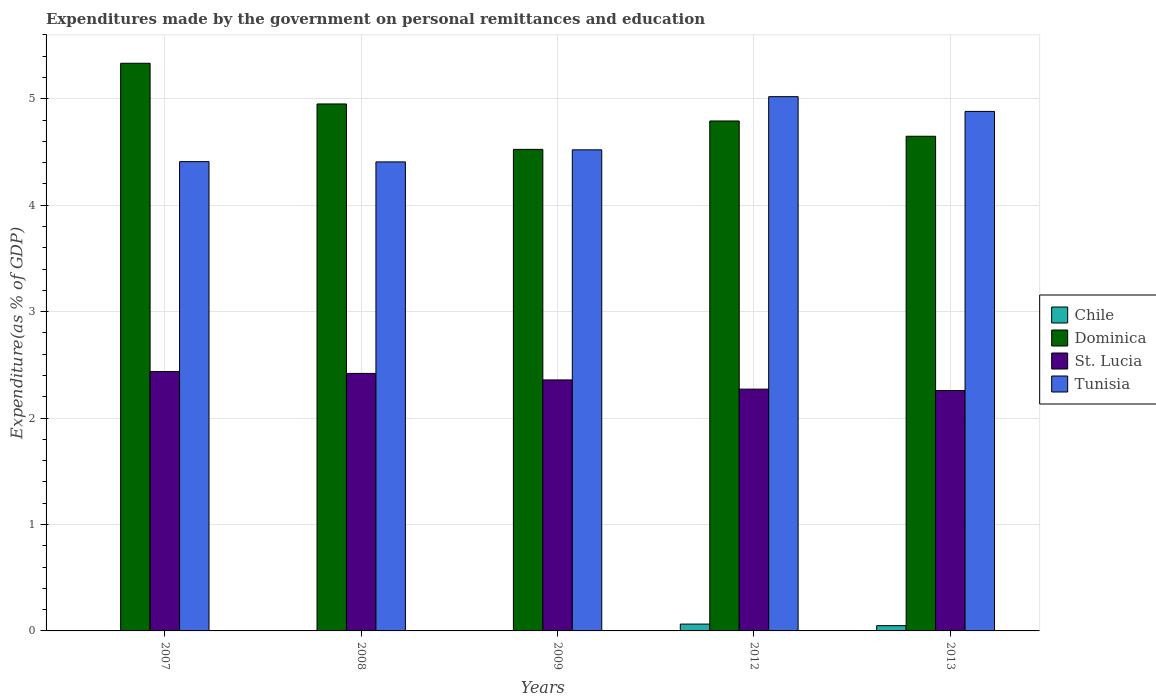How many different coloured bars are there?
Provide a short and direct response. 4. Are the number of bars per tick equal to the number of legend labels?
Your response must be concise. Yes. How many bars are there on the 5th tick from the right?
Your answer should be compact. 4. In how many cases, is the number of bars for a given year not equal to the number of legend labels?
Your answer should be very brief. 0. What is the expenditures made by the government on personal remittances and education in Chile in 2012?
Your answer should be compact. 0.06. Across all years, what is the maximum expenditures made by the government on personal remittances and education in Dominica?
Offer a terse response. 5.33. Across all years, what is the minimum expenditures made by the government on personal remittances and education in Tunisia?
Your answer should be very brief. 4.41. In which year was the expenditures made by the government on personal remittances and education in Chile minimum?
Ensure brevity in your answer.  2008. What is the total expenditures made by the government on personal remittances and education in St. Lucia in the graph?
Give a very brief answer. 11.75. What is the difference between the expenditures made by the government on personal remittances and education in St. Lucia in 2009 and that in 2012?
Ensure brevity in your answer.  0.09. What is the difference between the expenditures made by the government on personal remittances and education in Chile in 2007 and the expenditures made by the government on personal remittances and education in Tunisia in 2009?
Offer a terse response. -4.52. What is the average expenditures made by the government on personal remittances and education in Tunisia per year?
Your answer should be compact. 4.65. In the year 2013, what is the difference between the expenditures made by the government on personal remittances and education in Dominica and expenditures made by the government on personal remittances and education in Chile?
Provide a short and direct response. 4.6. What is the ratio of the expenditures made by the government on personal remittances and education in Tunisia in 2008 to that in 2009?
Make the answer very short. 0.97. Is the difference between the expenditures made by the government on personal remittances and education in Dominica in 2012 and 2013 greater than the difference between the expenditures made by the government on personal remittances and education in Chile in 2012 and 2013?
Ensure brevity in your answer.  Yes. What is the difference between the highest and the second highest expenditures made by the government on personal remittances and education in Tunisia?
Keep it short and to the point. 0.14. What is the difference between the highest and the lowest expenditures made by the government on personal remittances and education in Tunisia?
Ensure brevity in your answer.  0.61. Is it the case that in every year, the sum of the expenditures made by the government on personal remittances and education in Chile and expenditures made by the government on personal remittances and education in Dominica is greater than the sum of expenditures made by the government on personal remittances and education in Tunisia and expenditures made by the government on personal remittances and education in St. Lucia?
Offer a very short reply. Yes. What does the 3rd bar from the right in 2013 represents?
Your answer should be very brief. Dominica. Are all the bars in the graph horizontal?
Your answer should be compact. No. How many years are there in the graph?
Keep it short and to the point. 5. What is the difference between two consecutive major ticks on the Y-axis?
Your response must be concise. 1. Does the graph contain any zero values?
Give a very brief answer. No. Where does the legend appear in the graph?
Your answer should be compact. Center right. What is the title of the graph?
Offer a very short reply. Expenditures made by the government on personal remittances and education. What is the label or title of the Y-axis?
Provide a succinct answer. Expenditure(as % of GDP). What is the Expenditure(as % of GDP) of Chile in 2007?
Provide a short and direct response. 0. What is the Expenditure(as % of GDP) in Dominica in 2007?
Give a very brief answer. 5.33. What is the Expenditure(as % of GDP) in St. Lucia in 2007?
Make the answer very short. 2.44. What is the Expenditure(as % of GDP) in Tunisia in 2007?
Your answer should be very brief. 4.41. What is the Expenditure(as % of GDP) in Chile in 2008?
Offer a very short reply. 0. What is the Expenditure(as % of GDP) of Dominica in 2008?
Your response must be concise. 4.95. What is the Expenditure(as % of GDP) in St. Lucia in 2008?
Offer a terse response. 2.42. What is the Expenditure(as % of GDP) in Tunisia in 2008?
Your response must be concise. 4.41. What is the Expenditure(as % of GDP) in Chile in 2009?
Keep it short and to the point. 0. What is the Expenditure(as % of GDP) in Dominica in 2009?
Make the answer very short. 4.52. What is the Expenditure(as % of GDP) in St. Lucia in 2009?
Your answer should be very brief. 2.36. What is the Expenditure(as % of GDP) in Tunisia in 2009?
Offer a terse response. 4.52. What is the Expenditure(as % of GDP) of Chile in 2012?
Give a very brief answer. 0.06. What is the Expenditure(as % of GDP) of Dominica in 2012?
Your answer should be very brief. 4.79. What is the Expenditure(as % of GDP) in St. Lucia in 2012?
Ensure brevity in your answer.  2.27. What is the Expenditure(as % of GDP) in Tunisia in 2012?
Your response must be concise. 5.02. What is the Expenditure(as % of GDP) of Chile in 2013?
Offer a terse response. 0.05. What is the Expenditure(as % of GDP) of Dominica in 2013?
Ensure brevity in your answer.  4.65. What is the Expenditure(as % of GDP) of St. Lucia in 2013?
Provide a short and direct response. 2.26. What is the Expenditure(as % of GDP) of Tunisia in 2013?
Your answer should be compact. 4.88. Across all years, what is the maximum Expenditure(as % of GDP) of Chile?
Make the answer very short. 0.06. Across all years, what is the maximum Expenditure(as % of GDP) of Dominica?
Your response must be concise. 5.33. Across all years, what is the maximum Expenditure(as % of GDP) of St. Lucia?
Make the answer very short. 2.44. Across all years, what is the maximum Expenditure(as % of GDP) of Tunisia?
Your answer should be compact. 5.02. Across all years, what is the minimum Expenditure(as % of GDP) in Chile?
Offer a terse response. 0. Across all years, what is the minimum Expenditure(as % of GDP) in Dominica?
Your response must be concise. 4.52. Across all years, what is the minimum Expenditure(as % of GDP) in St. Lucia?
Ensure brevity in your answer.  2.26. Across all years, what is the minimum Expenditure(as % of GDP) in Tunisia?
Offer a terse response. 4.41. What is the total Expenditure(as % of GDP) in Chile in the graph?
Your answer should be compact. 0.12. What is the total Expenditure(as % of GDP) of Dominica in the graph?
Provide a short and direct response. 24.25. What is the total Expenditure(as % of GDP) of St. Lucia in the graph?
Offer a terse response. 11.75. What is the total Expenditure(as % of GDP) of Tunisia in the graph?
Provide a short and direct response. 23.24. What is the difference between the Expenditure(as % of GDP) of Dominica in 2007 and that in 2008?
Keep it short and to the point. 0.38. What is the difference between the Expenditure(as % of GDP) in St. Lucia in 2007 and that in 2008?
Your answer should be compact. 0.02. What is the difference between the Expenditure(as % of GDP) of Tunisia in 2007 and that in 2008?
Give a very brief answer. 0. What is the difference between the Expenditure(as % of GDP) of Chile in 2007 and that in 2009?
Keep it short and to the point. -0. What is the difference between the Expenditure(as % of GDP) of Dominica in 2007 and that in 2009?
Make the answer very short. 0.81. What is the difference between the Expenditure(as % of GDP) in St. Lucia in 2007 and that in 2009?
Provide a short and direct response. 0.08. What is the difference between the Expenditure(as % of GDP) of Tunisia in 2007 and that in 2009?
Offer a very short reply. -0.11. What is the difference between the Expenditure(as % of GDP) of Chile in 2007 and that in 2012?
Keep it short and to the point. -0.06. What is the difference between the Expenditure(as % of GDP) of Dominica in 2007 and that in 2012?
Your answer should be compact. 0.54. What is the difference between the Expenditure(as % of GDP) of St. Lucia in 2007 and that in 2012?
Ensure brevity in your answer.  0.17. What is the difference between the Expenditure(as % of GDP) of Tunisia in 2007 and that in 2012?
Provide a succinct answer. -0.61. What is the difference between the Expenditure(as % of GDP) of Chile in 2007 and that in 2013?
Your answer should be compact. -0.05. What is the difference between the Expenditure(as % of GDP) in Dominica in 2007 and that in 2013?
Your answer should be very brief. 0.69. What is the difference between the Expenditure(as % of GDP) of St. Lucia in 2007 and that in 2013?
Provide a short and direct response. 0.18. What is the difference between the Expenditure(as % of GDP) in Tunisia in 2007 and that in 2013?
Provide a succinct answer. -0.47. What is the difference between the Expenditure(as % of GDP) in Chile in 2008 and that in 2009?
Your answer should be very brief. -0. What is the difference between the Expenditure(as % of GDP) in Dominica in 2008 and that in 2009?
Give a very brief answer. 0.43. What is the difference between the Expenditure(as % of GDP) in St. Lucia in 2008 and that in 2009?
Your response must be concise. 0.06. What is the difference between the Expenditure(as % of GDP) in Tunisia in 2008 and that in 2009?
Offer a very short reply. -0.11. What is the difference between the Expenditure(as % of GDP) of Chile in 2008 and that in 2012?
Offer a very short reply. -0.06. What is the difference between the Expenditure(as % of GDP) of Dominica in 2008 and that in 2012?
Your answer should be compact. 0.16. What is the difference between the Expenditure(as % of GDP) in St. Lucia in 2008 and that in 2012?
Give a very brief answer. 0.15. What is the difference between the Expenditure(as % of GDP) of Tunisia in 2008 and that in 2012?
Offer a very short reply. -0.61. What is the difference between the Expenditure(as % of GDP) in Chile in 2008 and that in 2013?
Offer a very short reply. -0.05. What is the difference between the Expenditure(as % of GDP) in Dominica in 2008 and that in 2013?
Ensure brevity in your answer.  0.3. What is the difference between the Expenditure(as % of GDP) in St. Lucia in 2008 and that in 2013?
Make the answer very short. 0.16. What is the difference between the Expenditure(as % of GDP) of Tunisia in 2008 and that in 2013?
Ensure brevity in your answer.  -0.47. What is the difference between the Expenditure(as % of GDP) in Chile in 2009 and that in 2012?
Make the answer very short. -0.06. What is the difference between the Expenditure(as % of GDP) of Dominica in 2009 and that in 2012?
Your answer should be compact. -0.27. What is the difference between the Expenditure(as % of GDP) in St. Lucia in 2009 and that in 2012?
Your answer should be compact. 0.09. What is the difference between the Expenditure(as % of GDP) of Tunisia in 2009 and that in 2012?
Provide a succinct answer. -0.5. What is the difference between the Expenditure(as % of GDP) in Chile in 2009 and that in 2013?
Offer a terse response. -0.05. What is the difference between the Expenditure(as % of GDP) of Dominica in 2009 and that in 2013?
Give a very brief answer. -0.12. What is the difference between the Expenditure(as % of GDP) in St. Lucia in 2009 and that in 2013?
Your answer should be very brief. 0.1. What is the difference between the Expenditure(as % of GDP) in Tunisia in 2009 and that in 2013?
Your answer should be compact. -0.36. What is the difference between the Expenditure(as % of GDP) of Chile in 2012 and that in 2013?
Your answer should be compact. 0.01. What is the difference between the Expenditure(as % of GDP) in Dominica in 2012 and that in 2013?
Make the answer very short. 0.14. What is the difference between the Expenditure(as % of GDP) of St. Lucia in 2012 and that in 2013?
Offer a terse response. 0.01. What is the difference between the Expenditure(as % of GDP) of Tunisia in 2012 and that in 2013?
Offer a terse response. 0.14. What is the difference between the Expenditure(as % of GDP) of Chile in 2007 and the Expenditure(as % of GDP) of Dominica in 2008?
Your answer should be very brief. -4.95. What is the difference between the Expenditure(as % of GDP) in Chile in 2007 and the Expenditure(as % of GDP) in St. Lucia in 2008?
Your answer should be very brief. -2.42. What is the difference between the Expenditure(as % of GDP) of Chile in 2007 and the Expenditure(as % of GDP) of Tunisia in 2008?
Make the answer very short. -4.41. What is the difference between the Expenditure(as % of GDP) of Dominica in 2007 and the Expenditure(as % of GDP) of St. Lucia in 2008?
Ensure brevity in your answer.  2.91. What is the difference between the Expenditure(as % of GDP) in Dominica in 2007 and the Expenditure(as % of GDP) in Tunisia in 2008?
Ensure brevity in your answer.  0.93. What is the difference between the Expenditure(as % of GDP) of St. Lucia in 2007 and the Expenditure(as % of GDP) of Tunisia in 2008?
Keep it short and to the point. -1.97. What is the difference between the Expenditure(as % of GDP) in Chile in 2007 and the Expenditure(as % of GDP) in Dominica in 2009?
Provide a succinct answer. -4.52. What is the difference between the Expenditure(as % of GDP) in Chile in 2007 and the Expenditure(as % of GDP) in St. Lucia in 2009?
Provide a succinct answer. -2.36. What is the difference between the Expenditure(as % of GDP) in Chile in 2007 and the Expenditure(as % of GDP) in Tunisia in 2009?
Ensure brevity in your answer.  -4.52. What is the difference between the Expenditure(as % of GDP) of Dominica in 2007 and the Expenditure(as % of GDP) of St. Lucia in 2009?
Ensure brevity in your answer.  2.98. What is the difference between the Expenditure(as % of GDP) in Dominica in 2007 and the Expenditure(as % of GDP) in Tunisia in 2009?
Your answer should be compact. 0.81. What is the difference between the Expenditure(as % of GDP) of St. Lucia in 2007 and the Expenditure(as % of GDP) of Tunisia in 2009?
Give a very brief answer. -2.08. What is the difference between the Expenditure(as % of GDP) of Chile in 2007 and the Expenditure(as % of GDP) of Dominica in 2012?
Make the answer very short. -4.79. What is the difference between the Expenditure(as % of GDP) of Chile in 2007 and the Expenditure(as % of GDP) of St. Lucia in 2012?
Keep it short and to the point. -2.27. What is the difference between the Expenditure(as % of GDP) of Chile in 2007 and the Expenditure(as % of GDP) of Tunisia in 2012?
Keep it short and to the point. -5.02. What is the difference between the Expenditure(as % of GDP) in Dominica in 2007 and the Expenditure(as % of GDP) in St. Lucia in 2012?
Provide a succinct answer. 3.06. What is the difference between the Expenditure(as % of GDP) in Dominica in 2007 and the Expenditure(as % of GDP) in Tunisia in 2012?
Give a very brief answer. 0.31. What is the difference between the Expenditure(as % of GDP) of St. Lucia in 2007 and the Expenditure(as % of GDP) of Tunisia in 2012?
Provide a succinct answer. -2.58. What is the difference between the Expenditure(as % of GDP) in Chile in 2007 and the Expenditure(as % of GDP) in Dominica in 2013?
Offer a very short reply. -4.65. What is the difference between the Expenditure(as % of GDP) in Chile in 2007 and the Expenditure(as % of GDP) in St. Lucia in 2013?
Provide a succinct answer. -2.26. What is the difference between the Expenditure(as % of GDP) in Chile in 2007 and the Expenditure(as % of GDP) in Tunisia in 2013?
Provide a short and direct response. -4.88. What is the difference between the Expenditure(as % of GDP) of Dominica in 2007 and the Expenditure(as % of GDP) of St. Lucia in 2013?
Ensure brevity in your answer.  3.07. What is the difference between the Expenditure(as % of GDP) in Dominica in 2007 and the Expenditure(as % of GDP) in Tunisia in 2013?
Offer a terse response. 0.45. What is the difference between the Expenditure(as % of GDP) of St. Lucia in 2007 and the Expenditure(as % of GDP) of Tunisia in 2013?
Offer a very short reply. -2.44. What is the difference between the Expenditure(as % of GDP) of Chile in 2008 and the Expenditure(as % of GDP) of Dominica in 2009?
Keep it short and to the point. -4.52. What is the difference between the Expenditure(as % of GDP) in Chile in 2008 and the Expenditure(as % of GDP) in St. Lucia in 2009?
Offer a very short reply. -2.36. What is the difference between the Expenditure(as % of GDP) in Chile in 2008 and the Expenditure(as % of GDP) in Tunisia in 2009?
Your response must be concise. -4.52. What is the difference between the Expenditure(as % of GDP) of Dominica in 2008 and the Expenditure(as % of GDP) of St. Lucia in 2009?
Your answer should be very brief. 2.59. What is the difference between the Expenditure(as % of GDP) in Dominica in 2008 and the Expenditure(as % of GDP) in Tunisia in 2009?
Provide a succinct answer. 0.43. What is the difference between the Expenditure(as % of GDP) of St. Lucia in 2008 and the Expenditure(as % of GDP) of Tunisia in 2009?
Your answer should be compact. -2.1. What is the difference between the Expenditure(as % of GDP) in Chile in 2008 and the Expenditure(as % of GDP) in Dominica in 2012?
Give a very brief answer. -4.79. What is the difference between the Expenditure(as % of GDP) of Chile in 2008 and the Expenditure(as % of GDP) of St. Lucia in 2012?
Provide a short and direct response. -2.27. What is the difference between the Expenditure(as % of GDP) of Chile in 2008 and the Expenditure(as % of GDP) of Tunisia in 2012?
Make the answer very short. -5.02. What is the difference between the Expenditure(as % of GDP) of Dominica in 2008 and the Expenditure(as % of GDP) of St. Lucia in 2012?
Your response must be concise. 2.68. What is the difference between the Expenditure(as % of GDP) of Dominica in 2008 and the Expenditure(as % of GDP) of Tunisia in 2012?
Give a very brief answer. -0.07. What is the difference between the Expenditure(as % of GDP) of St. Lucia in 2008 and the Expenditure(as % of GDP) of Tunisia in 2012?
Offer a terse response. -2.6. What is the difference between the Expenditure(as % of GDP) of Chile in 2008 and the Expenditure(as % of GDP) of Dominica in 2013?
Your answer should be very brief. -4.65. What is the difference between the Expenditure(as % of GDP) in Chile in 2008 and the Expenditure(as % of GDP) in St. Lucia in 2013?
Ensure brevity in your answer.  -2.26. What is the difference between the Expenditure(as % of GDP) in Chile in 2008 and the Expenditure(as % of GDP) in Tunisia in 2013?
Ensure brevity in your answer.  -4.88. What is the difference between the Expenditure(as % of GDP) of Dominica in 2008 and the Expenditure(as % of GDP) of St. Lucia in 2013?
Your answer should be very brief. 2.69. What is the difference between the Expenditure(as % of GDP) in Dominica in 2008 and the Expenditure(as % of GDP) in Tunisia in 2013?
Provide a succinct answer. 0.07. What is the difference between the Expenditure(as % of GDP) in St. Lucia in 2008 and the Expenditure(as % of GDP) in Tunisia in 2013?
Ensure brevity in your answer.  -2.46. What is the difference between the Expenditure(as % of GDP) of Chile in 2009 and the Expenditure(as % of GDP) of Dominica in 2012?
Keep it short and to the point. -4.79. What is the difference between the Expenditure(as % of GDP) of Chile in 2009 and the Expenditure(as % of GDP) of St. Lucia in 2012?
Provide a succinct answer. -2.27. What is the difference between the Expenditure(as % of GDP) in Chile in 2009 and the Expenditure(as % of GDP) in Tunisia in 2012?
Provide a succinct answer. -5.02. What is the difference between the Expenditure(as % of GDP) of Dominica in 2009 and the Expenditure(as % of GDP) of St. Lucia in 2012?
Offer a terse response. 2.25. What is the difference between the Expenditure(as % of GDP) of Dominica in 2009 and the Expenditure(as % of GDP) of Tunisia in 2012?
Offer a terse response. -0.5. What is the difference between the Expenditure(as % of GDP) of St. Lucia in 2009 and the Expenditure(as % of GDP) of Tunisia in 2012?
Your answer should be compact. -2.66. What is the difference between the Expenditure(as % of GDP) of Chile in 2009 and the Expenditure(as % of GDP) of Dominica in 2013?
Your response must be concise. -4.65. What is the difference between the Expenditure(as % of GDP) in Chile in 2009 and the Expenditure(as % of GDP) in St. Lucia in 2013?
Give a very brief answer. -2.26. What is the difference between the Expenditure(as % of GDP) in Chile in 2009 and the Expenditure(as % of GDP) in Tunisia in 2013?
Ensure brevity in your answer.  -4.88. What is the difference between the Expenditure(as % of GDP) in Dominica in 2009 and the Expenditure(as % of GDP) in St. Lucia in 2013?
Provide a succinct answer. 2.27. What is the difference between the Expenditure(as % of GDP) of Dominica in 2009 and the Expenditure(as % of GDP) of Tunisia in 2013?
Ensure brevity in your answer.  -0.36. What is the difference between the Expenditure(as % of GDP) in St. Lucia in 2009 and the Expenditure(as % of GDP) in Tunisia in 2013?
Offer a very short reply. -2.52. What is the difference between the Expenditure(as % of GDP) of Chile in 2012 and the Expenditure(as % of GDP) of Dominica in 2013?
Your answer should be very brief. -4.58. What is the difference between the Expenditure(as % of GDP) in Chile in 2012 and the Expenditure(as % of GDP) in St. Lucia in 2013?
Provide a succinct answer. -2.19. What is the difference between the Expenditure(as % of GDP) of Chile in 2012 and the Expenditure(as % of GDP) of Tunisia in 2013?
Keep it short and to the point. -4.82. What is the difference between the Expenditure(as % of GDP) in Dominica in 2012 and the Expenditure(as % of GDP) in St. Lucia in 2013?
Provide a succinct answer. 2.53. What is the difference between the Expenditure(as % of GDP) in Dominica in 2012 and the Expenditure(as % of GDP) in Tunisia in 2013?
Make the answer very short. -0.09. What is the difference between the Expenditure(as % of GDP) in St. Lucia in 2012 and the Expenditure(as % of GDP) in Tunisia in 2013?
Provide a succinct answer. -2.61. What is the average Expenditure(as % of GDP) of Chile per year?
Your answer should be very brief. 0.02. What is the average Expenditure(as % of GDP) of Dominica per year?
Offer a very short reply. 4.85. What is the average Expenditure(as % of GDP) of St. Lucia per year?
Your answer should be very brief. 2.35. What is the average Expenditure(as % of GDP) in Tunisia per year?
Your response must be concise. 4.65. In the year 2007, what is the difference between the Expenditure(as % of GDP) in Chile and Expenditure(as % of GDP) in Dominica?
Keep it short and to the point. -5.33. In the year 2007, what is the difference between the Expenditure(as % of GDP) of Chile and Expenditure(as % of GDP) of St. Lucia?
Make the answer very short. -2.44. In the year 2007, what is the difference between the Expenditure(as % of GDP) in Chile and Expenditure(as % of GDP) in Tunisia?
Your answer should be compact. -4.41. In the year 2007, what is the difference between the Expenditure(as % of GDP) of Dominica and Expenditure(as % of GDP) of St. Lucia?
Provide a short and direct response. 2.9. In the year 2007, what is the difference between the Expenditure(as % of GDP) of Dominica and Expenditure(as % of GDP) of Tunisia?
Offer a terse response. 0.92. In the year 2007, what is the difference between the Expenditure(as % of GDP) in St. Lucia and Expenditure(as % of GDP) in Tunisia?
Your response must be concise. -1.97. In the year 2008, what is the difference between the Expenditure(as % of GDP) of Chile and Expenditure(as % of GDP) of Dominica?
Offer a very short reply. -4.95. In the year 2008, what is the difference between the Expenditure(as % of GDP) in Chile and Expenditure(as % of GDP) in St. Lucia?
Keep it short and to the point. -2.42. In the year 2008, what is the difference between the Expenditure(as % of GDP) of Chile and Expenditure(as % of GDP) of Tunisia?
Keep it short and to the point. -4.41. In the year 2008, what is the difference between the Expenditure(as % of GDP) in Dominica and Expenditure(as % of GDP) in St. Lucia?
Provide a short and direct response. 2.53. In the year 2008, what is the difference between the Expenditure(as % of GDP) of Dominica and Expenditure(as % of GDP) of Tunisia?
Your answer should be very brief. 0.54. In the year 2008, what is the difference between the Expenditure(as % of GDP) in St. Lucia and Expenditure(as % of GDP) in Tunisia?
Your answer should be compact. -1.99. In the year 2009, what is the difference between the Expenditure(as % of GDP) of Chile and Expenditure(as % of GDP) of Dominica?
Your answer should be compact. -4.52. In the year 2009, what is the difference between the Expenditure(as % of GDP) in Chile and Expenditure(as % of GDP) in St. Lucia?
Provide a succinct answer. -2.36. In the year 2009, what is the difference between the Expenditure(as % of GDP) of Chile and Expenditure(as % of GDP) of Tunisia?
Offer a very short reply. -4.52. In the year 2009, what is the difference between the Expenditure(as % of GDP) in Dominica and Expenditure(as % of GDP) in St. Lucia?
Offer a very short reply. 2.17. In the year 2009, what is the difference between the Expenditure(as % of GDP) of Dominica and Expenditure(as % of GDP) of Tunisia?
Offer a very short reply. 0. In the year 2009, what is the difference between the Expenditure(as % of GDP) of St. Lucia and Expenditure(as % of GDP) of Tunisia?
Offer a terse response. -2.16. In the year 2012, what is the difference between the Expenditure(as % of GDP) of Chile and Expenditure(as % of GDP) of Dominica?
Your response must be concise. -4.73. In the year 2012, what is the difference between the Expenditure(as % of GDP) of Chile and Expenditure(as % of GDP) of St. Lucia?
Offer a very short reply. -2.21. In the year 2012, what is the difference between the Expenditure(as % of GDP) of Chile and Expenditure(as % of GDP) of Tunisia?
Offer a terse response. -4.96. In the year 2012, what is the difference between the Expenditure(as % of GDP) of Dominica and Expenditure(as % of GDP) of St. Lucia?
Provide a succinct answer. 2.52. In the year 2012, what is the difference between the Expenditure(as % of GDP) in Dominica and Expenditure(as % of GDP) in Tunisia?
Your answer should be very brief. -0.23. In the year 2012, what is the difference between the Expenditure(as % of GDP) of St. Lucia and Expenditure(as % of GDP) of Tunisia?
Ensure brevity in your answer.  -2.75. In the year 2013, what is the difference between the Expenditure(as % of GDP) of Chile and Expenditure(as % of GDP) of Dominica?
Your response must be concise. -4.6. In the year 2013, what is the difference between the Expenditure(as % of GDP) of Chile and Expenditure(as % of GDP) of St. Lucia?
Offer a terse response. -2.21. In the year 2013, what is the difference between the Expenditure(as % of GDP) in Chile and Expenditure(as % of GDP) in Tunisia?
Provide a succinct answer. -4.83. In the year 2013, what is the difference between the Expenditure(as % of GDP) of Dominica and Expenditure(as % of GDP) of St. Lucia?
Provide a succinct answer. 2.39. In the year 2013, what is the difference between the Expenditure(as % of GDP) of Dominica and Expenditure(as % of GDP) of Tunisia?
Offer a very short reply. -0.23. In the year 2013, what is the difference between the Expenditure(as % of GDP) in St. Lucia and Expenditure(as % of GDP) in Tunisia?
Your response must be concise. -2.62. What is the ratio of the Expenditure(as % of GDP) in Chile in 2007 to that in 2008?
Your response must be concise. 1.04. What is the ratio of the Expenditure(as % of GDP) of Dominica in 2007 to that in 2008?
Your answer should be compact. 1.08. What is the ratio of the Expenditure(as % of GDP) in St. Lucia in 2007 to that in 2008?
Provide a short and direct response. 1.01. What is the ratio of the Expenditure(as % of GDP) in Tunisia in 2007 to that in 2008?
Offer a very short reply. 1. What is the ratio of the Expenditure(as % of GDP) in Chile in 2007 to that in 2009?
Ensure brevity in your answer.  0.56. What is the ratio of the Expenditure(as % of GDP) of Dominica in 2007 to that in 2009?
Offer a terse response. 1.18. What is the ratio of the Expenditure(as % of GDP) in St. Lucia in 2007 to that in 2009?
Offer a terse response. 1.03. What is the ratio of the Expenditure(as % of GDP) in Tunisia in 2007 to that in 2009?
Provide a short and direct response. 0.98. What is the ratio of the Expenditure(as % of GDP) in Chile in 2007 to that in 2012?
Make the answer very short. 0.02. What is the ratio of the Expenditure(as % of GDP) in Dominica in 2007 to that in 2012?
Give a very brief answer. 1.11. What is the ratio of the Expenditure(as % of GDP) in St. Lucia in 2007 to that in 2012?
Give a very brief answer. 1.07. What is the ratio of the Expenditure(as % of GDP) of Tunisia in 2007 to that in 2012?
Provide a short and direct response. 0.88. What is the ratio of the Expenditure(as % of GDP) in Chile in 2007 to that in 2013?
Provide a short and direct response. 0.03. What is the ratio of the Expenditure(as % of GDP) of Dominica in 2007 to that in 2013?
Provide a succinct answer. 1.15. What is the ratio of the Expenditure(as % of GDP) of St. Lucia in 2007 to that in 2013?
Ensure brevity in your answer.  1.08. What is the ratio of the Expenditure(as % of GDP) in Tunisia in 2007 to that in 2013?
Provide a short and direct response. 0.9. What is the ratio of the Expenditure(as % of GDP) in Chile in 2008 to that in 2009?
Your answer should be very brief. 0.54. What is the ratio of the Expenditure(as % of GDP) of Dominica in 2008 to that in 2009?
Offer a terse response. 1.09. What is the ratio of the Expenditure(as % of GDP) in St. Lucia in 2008 to that in 2009?
Make the answer very short. 1.03. What is the ratio of the Expenditure(as % of GDP) in Tunisia in 2008 to that in 2009?
Provide a short and direct response. 0.97. What is the ratio of the Expenditure(as % of GDP) in Chile in 2008 to that in 2012?
Ensure brevity in your answer.  0.02. What is the ratio of the Expenditure(as % of GDP) in Dominica in 2008 to that in 2012?
Provide a succinct answer. 1.03. What is the ratio of the Expenditure(as % of GDP) of St. Lucia in 2008 to that in 2012?
Your response must be concise. 1.06. What is the ratio of the Expenditure(as % of GDP) of Tunisia in 2008 to that in 2012?
Your answer should be very brief. 0.88. What is the ratio of the Expenditure(as % of GDP) of Chile in 2008 to that in 2013?
Give a very brief answer. 0.03. What is the ratio of the Expenditure(as % of GDP) of Dominica in 2008 to that in 2013?
Keep it short and to the point. 1.07. What is the ratio of the Expenditure(as % of GDP) of St. Lucia in 2008 to that in 2013?
Provide a succinct answer. 1.07. What is the ratio of the Expenditure(as % of GDP) of Tunisia in 2008 to that in 2013?
Offer a terse response. 0.9. What is the ratio of the Expenditure(as % of GDP) of Chile in 2009 to that in 2012?
Ensure brevity in your answer.  0.04. What is the ratio of the Expenditure(as % of GDP) of Dominica in 2009 to that in 2012?
Give a very brief answer. 0.94. What is the ratio of the Expenditure(as % of GDP) of St. Lucia in 2009 to that in 2012?
Give a very brief answer. 1.04. What is the ratio of the Expenditure(as % of GDP) in Tunisia in 2009 to that in 2012?
Your response must be concise. 0.9. What is the ratio of the Expenditure(as % of GDP) in Chile in 2009 to that in 2013?
Provide a short and direct response. 0.05. What is the ratio of the Expenditure(as % of GDP) in Dominica in 2009 to that in 2013?
Provide a succinct answer. 0.97. What is the ratio of the Expenditure(as % of GDP) in St. Lucia in 2009 to that in 2013?
Keep it short and to the point. 1.04. What is the ratio of the Expenditure(as % of GDP) in Tunisia in 2009 to that in 2013?
Offer a very short reply. 0.93. What is the ratio of the Expenditure(as % of GDP) in Chile in 2012 to that in 2013?
Make the answer very short. 1.3. What is the ratio of the Expenditure(as % of GDP) in Dominica in 2012 to that in 2013?
Your answer should be compact. 1.03. What is the ratio of the Expenditure(as % of GDP) of Tunisia in 2012 to that in 2013?
Ensure brevity in your answer.  1.03. What is the difference between the highest and the second highest Expenditure(as % of GDP) in Chile?
Provide a succinct answer. 0.01. What is the difference between the highest and the second highest Expenditure(as % of GDP) in Dominica?
Offer a very short reply. 0.38. What is the difference between the highest and the second highest Expenditure(as % of GDP) of St. Lucia?
Your answer should be compact. 0.02. What is the difference between the highest and the second highest Expenditure(as % of GDP) of Tunisia?
Offer a terse response. 0.14. What is the difference between the highest and the lowest Expenditure(as % of GDP) of Chile?
Keep it short and to the point. 0.06. What is the difference between the highest and the lowest Expenditure(as % of GDP) in Dominica?
Ensure brevity in your answer.  0.81. What is the difference between the highest and the lowest Expenditure(as % of GDP) in St. Lucia?
Make the answer very short. 0.18. What is the difference between the highest and the lowest Expenditure(as % of GDP) in Tunisia?
Offer a terse response. 0.61. 